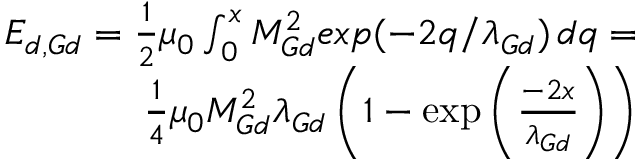<formula> <loc_0><loc_0><loc_500><loc_500>\begin{array} { r } { E _ { d , G d } = \frac { 1 } { 2 } \mu _ { 0 } \int _ { 0 } ^ { x } M _ { G d } ^ { 2 } e x p ( - 2 q / \lambda _ { G d } ) \, d q = } \\ { \frac { 1 } { 4 } \mu _ { 0 } M _ { G d } ^ { 2 } \lambda _ { G d } \left ( 1 - \exp \left ( \frac { - 2 x } { \lambda _ { G d } } \right ) \right ) } \end{array}</formula> 